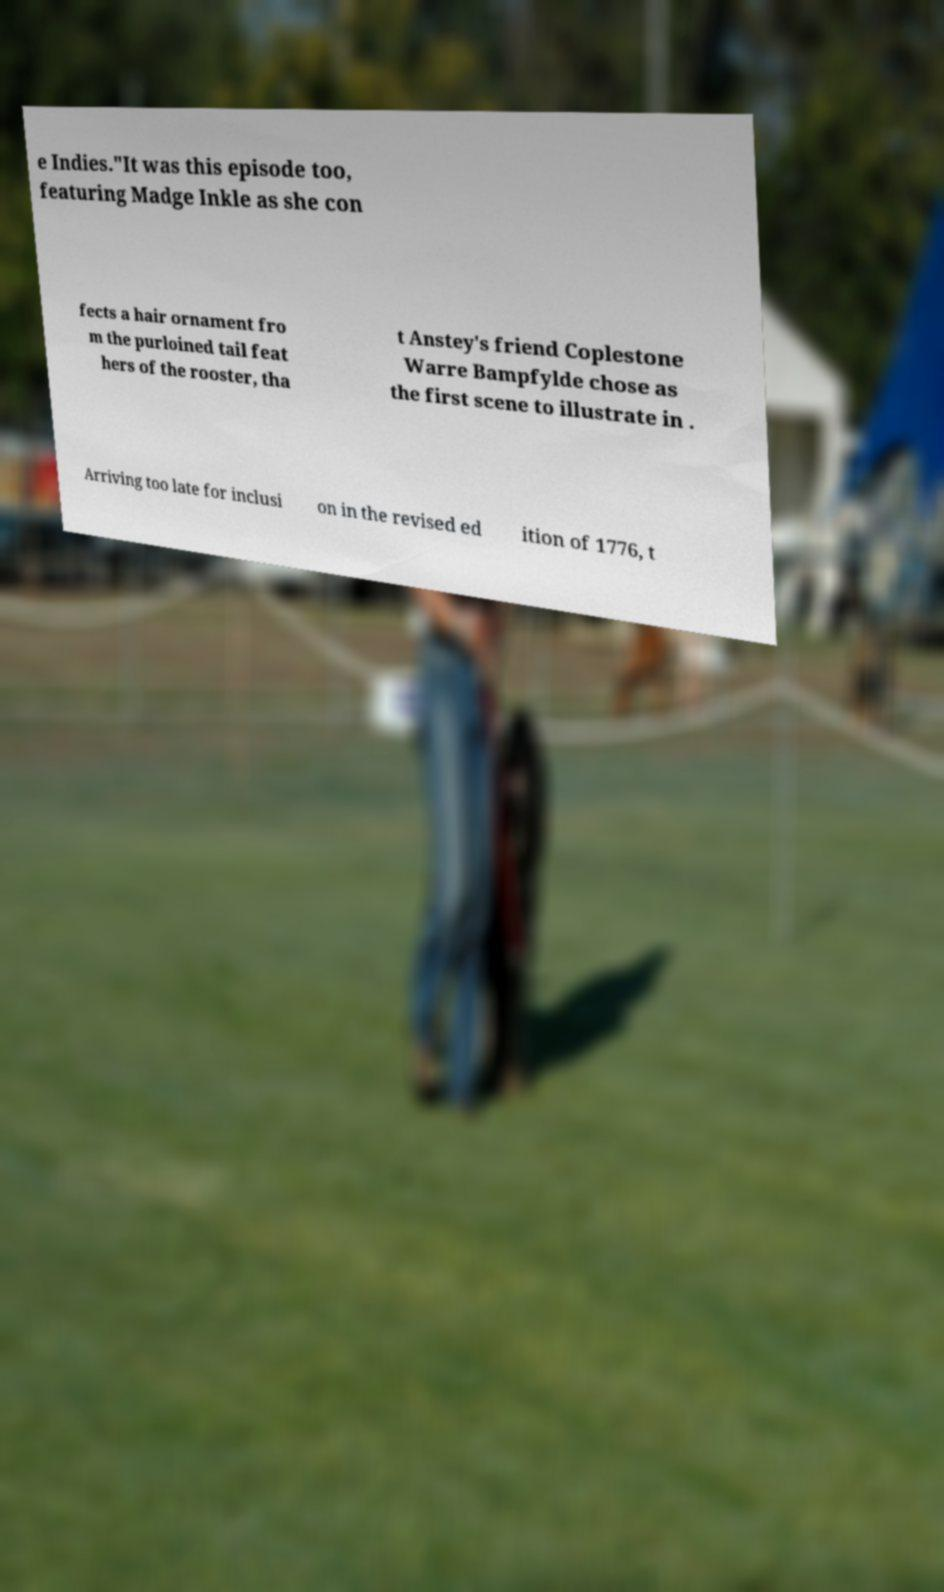There's text embedded in this image that I need extracted. Can you transcribe it verbatim? e Indies."It was this episode too, featuring Madge Inkle as she con fects a hair ornament fro m the purloined tail feat hers of the rooster, tha t Anstey's friend Coplestone Warre Bampfylde chose as the first scene to illustrate in . Arriving too late for inclusi on in the revised ed ition of 1776, t 